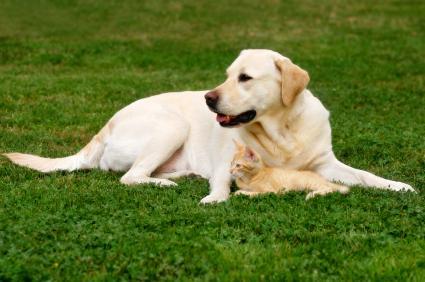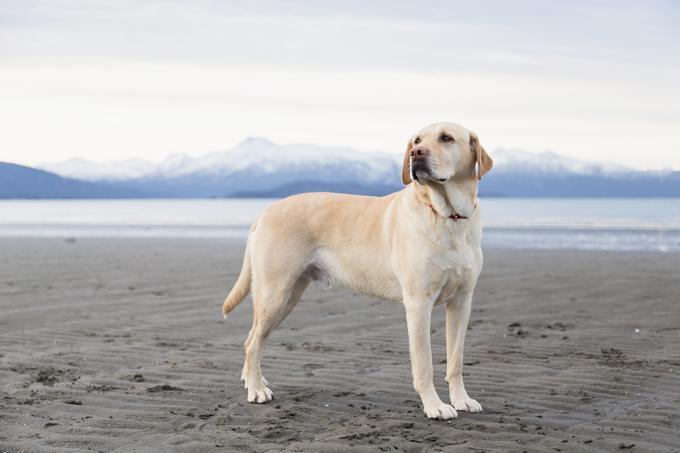The first image is the image on the left, the second image is the image on the right. Assess this claim about the two images: "the dog on the right image has its mouth open". Correct or not? Answer yes or no. No. 